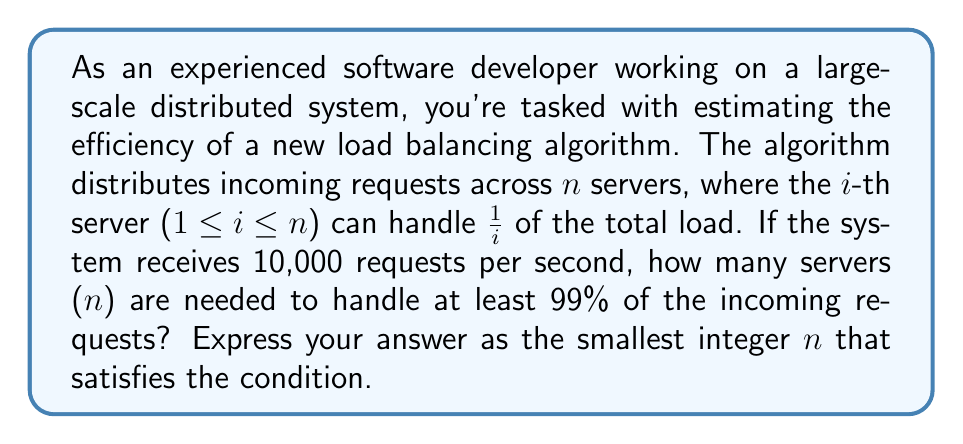What is the answer to this math problem? To solve this problem, we need to use the properties of the harmonic series and its partial sums. Let's approach this step-by-step:

1) The load handled by each server forms a harmonic series:

   $$\frac{1}{1} + \frac{1}{2} + \frac{1}{3} + ... + \frac{1}{n}$$

2) We need to find n such that the sum of this series is greater than or equal to 0.99 (99% of the load):

   $$\sum_{i=1}^n \frac{1}{i} \geq 0.99$$

3) This sum is known as the n-th partial sum of the harmonic series, often denoted as $H_n$. There's no closed-form expression for $H_n$, but we can use the following approximation:

   $$H_n \approx \ln(n) + \gamma$$

   Where $\gamma$ is the Euler-Mascheroni constant, approximately 0.5772156649.

4) Using this approximation, we need to solve:

   $$\ln(n) + 0.5772156649 \geq 0.99$$

5) Solving for n:

   $$\ln(n) \geq 0.4127843351$$
   $$n \geq e^{0.4127843351}$$
   $$n \geq 1.5110$$

6) Since n must be an integer and we need the smallest n that satisfies the condition, we round up to the nearest integer.

Therefore, we need at least 2 servers to handle 99% of the incoming requests.

7) To verify, let's calculate the exact sum for n = 2:

   $$H_2 = \frac{1}{1} + \frac{1}{2} = 1.5$$

   Which is indeed greater than 0.99.
Answer: 2 servers 